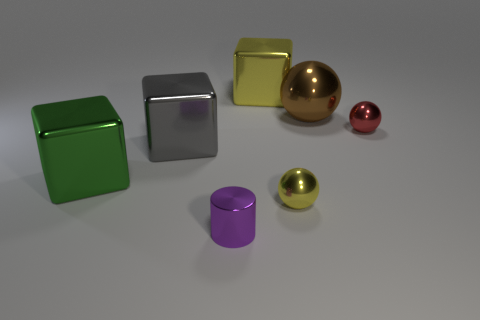There is a sphere in front of the green thing; is its color the same as the cube right of the small purple cylinder?
Give a very brief answer. Yes. How big is the cube that is on the right side of the tiny shiny thing that is to the left of the metallic sphere that is in front of the green block?
Give a very brief answer. Large. What number of other things are there of the same material as the brown ball
Provide a short and direct response. 6. There is a shiny sphere that is left of the brown ball; what size is it?
Offer a terse response. Small. What number of shiny objects are both in front of the brown object and on the left side of the brown thing?
Ensure brevity in your answer.  4. What is the material of the large gray cube that is in front of the block that is on the right side of the tiny purple metal thing?
Keep it short and to the point. Metal. There is a large green thing that is the same shape as the large yellow metal object; what is its material?
Ensure brevity in your answer.  Metal. Are there any yellow metallic balls?
Make the answer very short. Yes. The tiny red thing that is made of the same material as the small purple cylinder is what shape?
Your answer should be very brief. Sphere. There is a purple cylinder that is on the left side of the large yellow cube; what is it made of?
Give a very brief answer. Metal. 